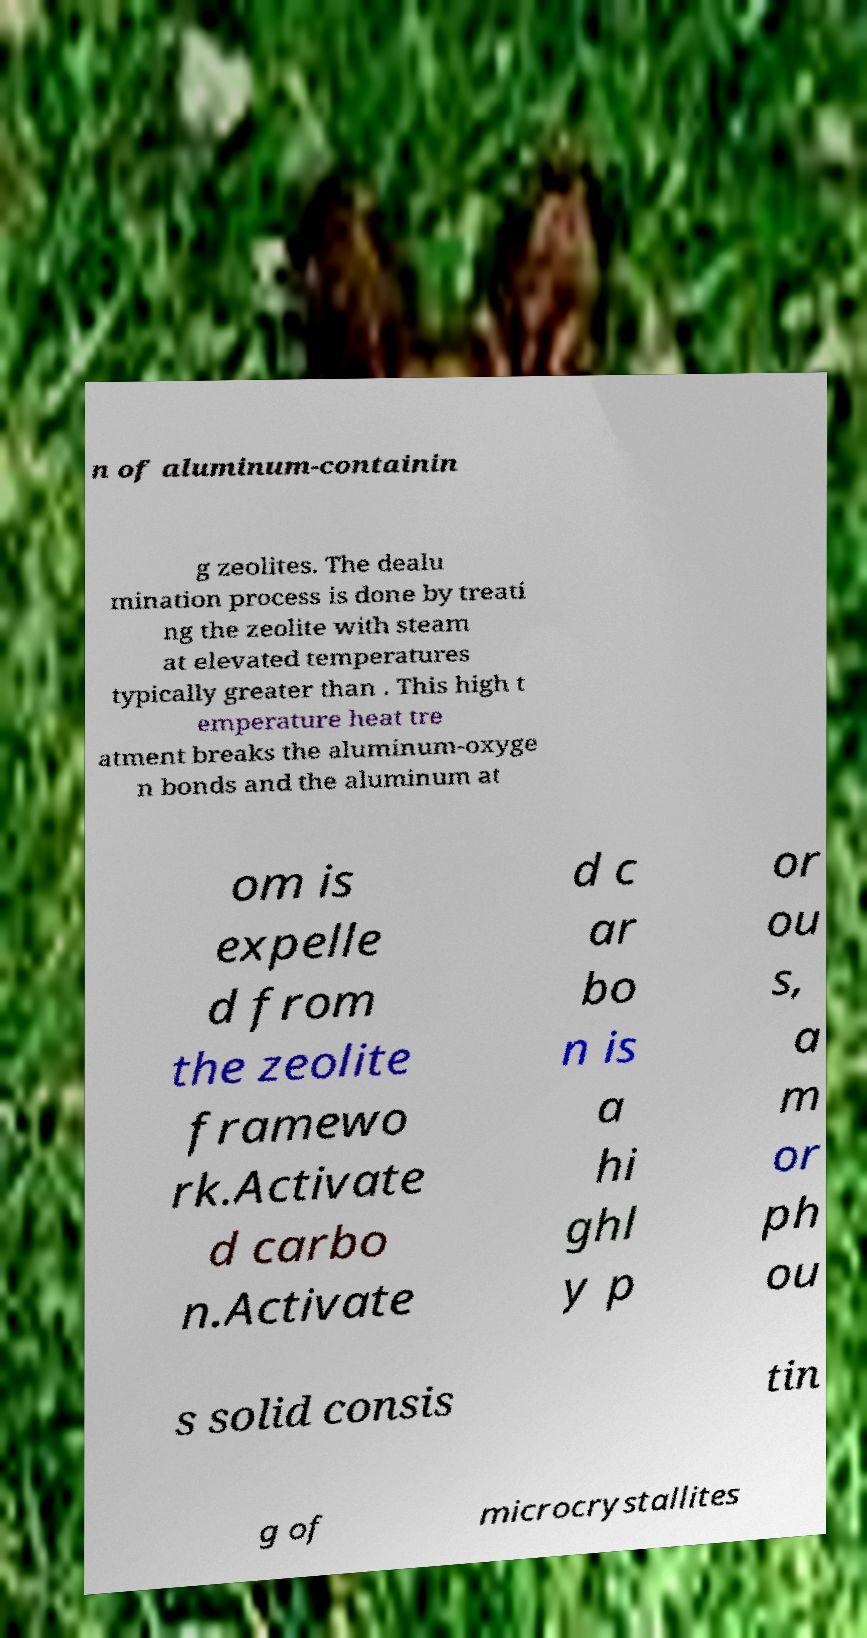Please identify and transcribe the text found in this image. n of aluminum-containin g zeolites. The dealu mination process is done by treati ng the zeolite with steam at elevated temperatures typically greater than . This high t emperature heat tre atment breaks the aluminum-oxyge n bonds and the aluminum at om is expelle d from the zeolite framewo rk.Activate d carbo n.Activate d c ar bo n is a hi ghl y p or ou s, a m or ph ou s solid consis tin g of microcrystallites 